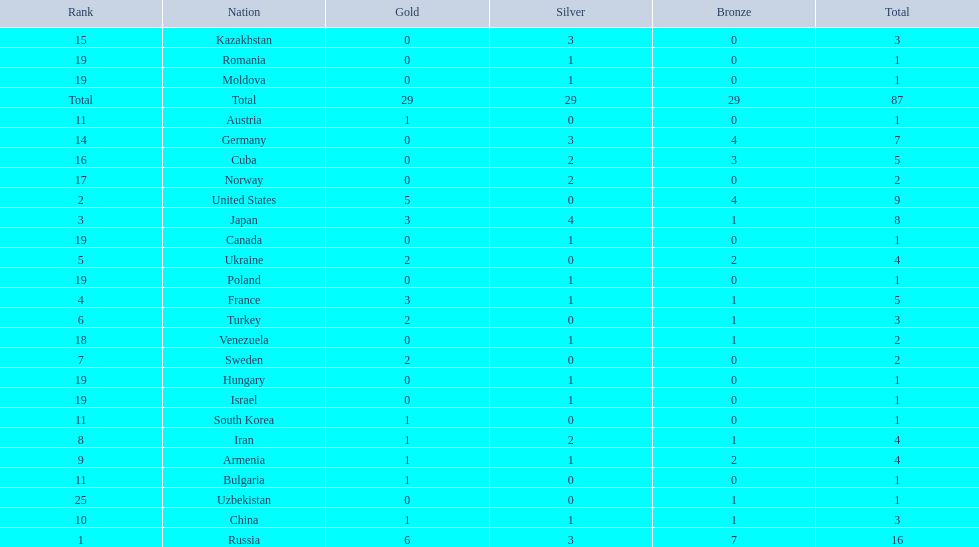Which nations participated in the 1995 world wrestling championships? Russia, United States, Japan, France, Ukraine, Turkey, Sweden, Iran, Armenia, China, Austria, Bulgaria, South Korea, Germany, Kazakhstan, Cuba, Norway, Venezuela, Canada, Hungary, Israel, Moldova, Poland, Romania, Uzbekistan. And between iran and germany, which one placed in the top 10? Germany. 